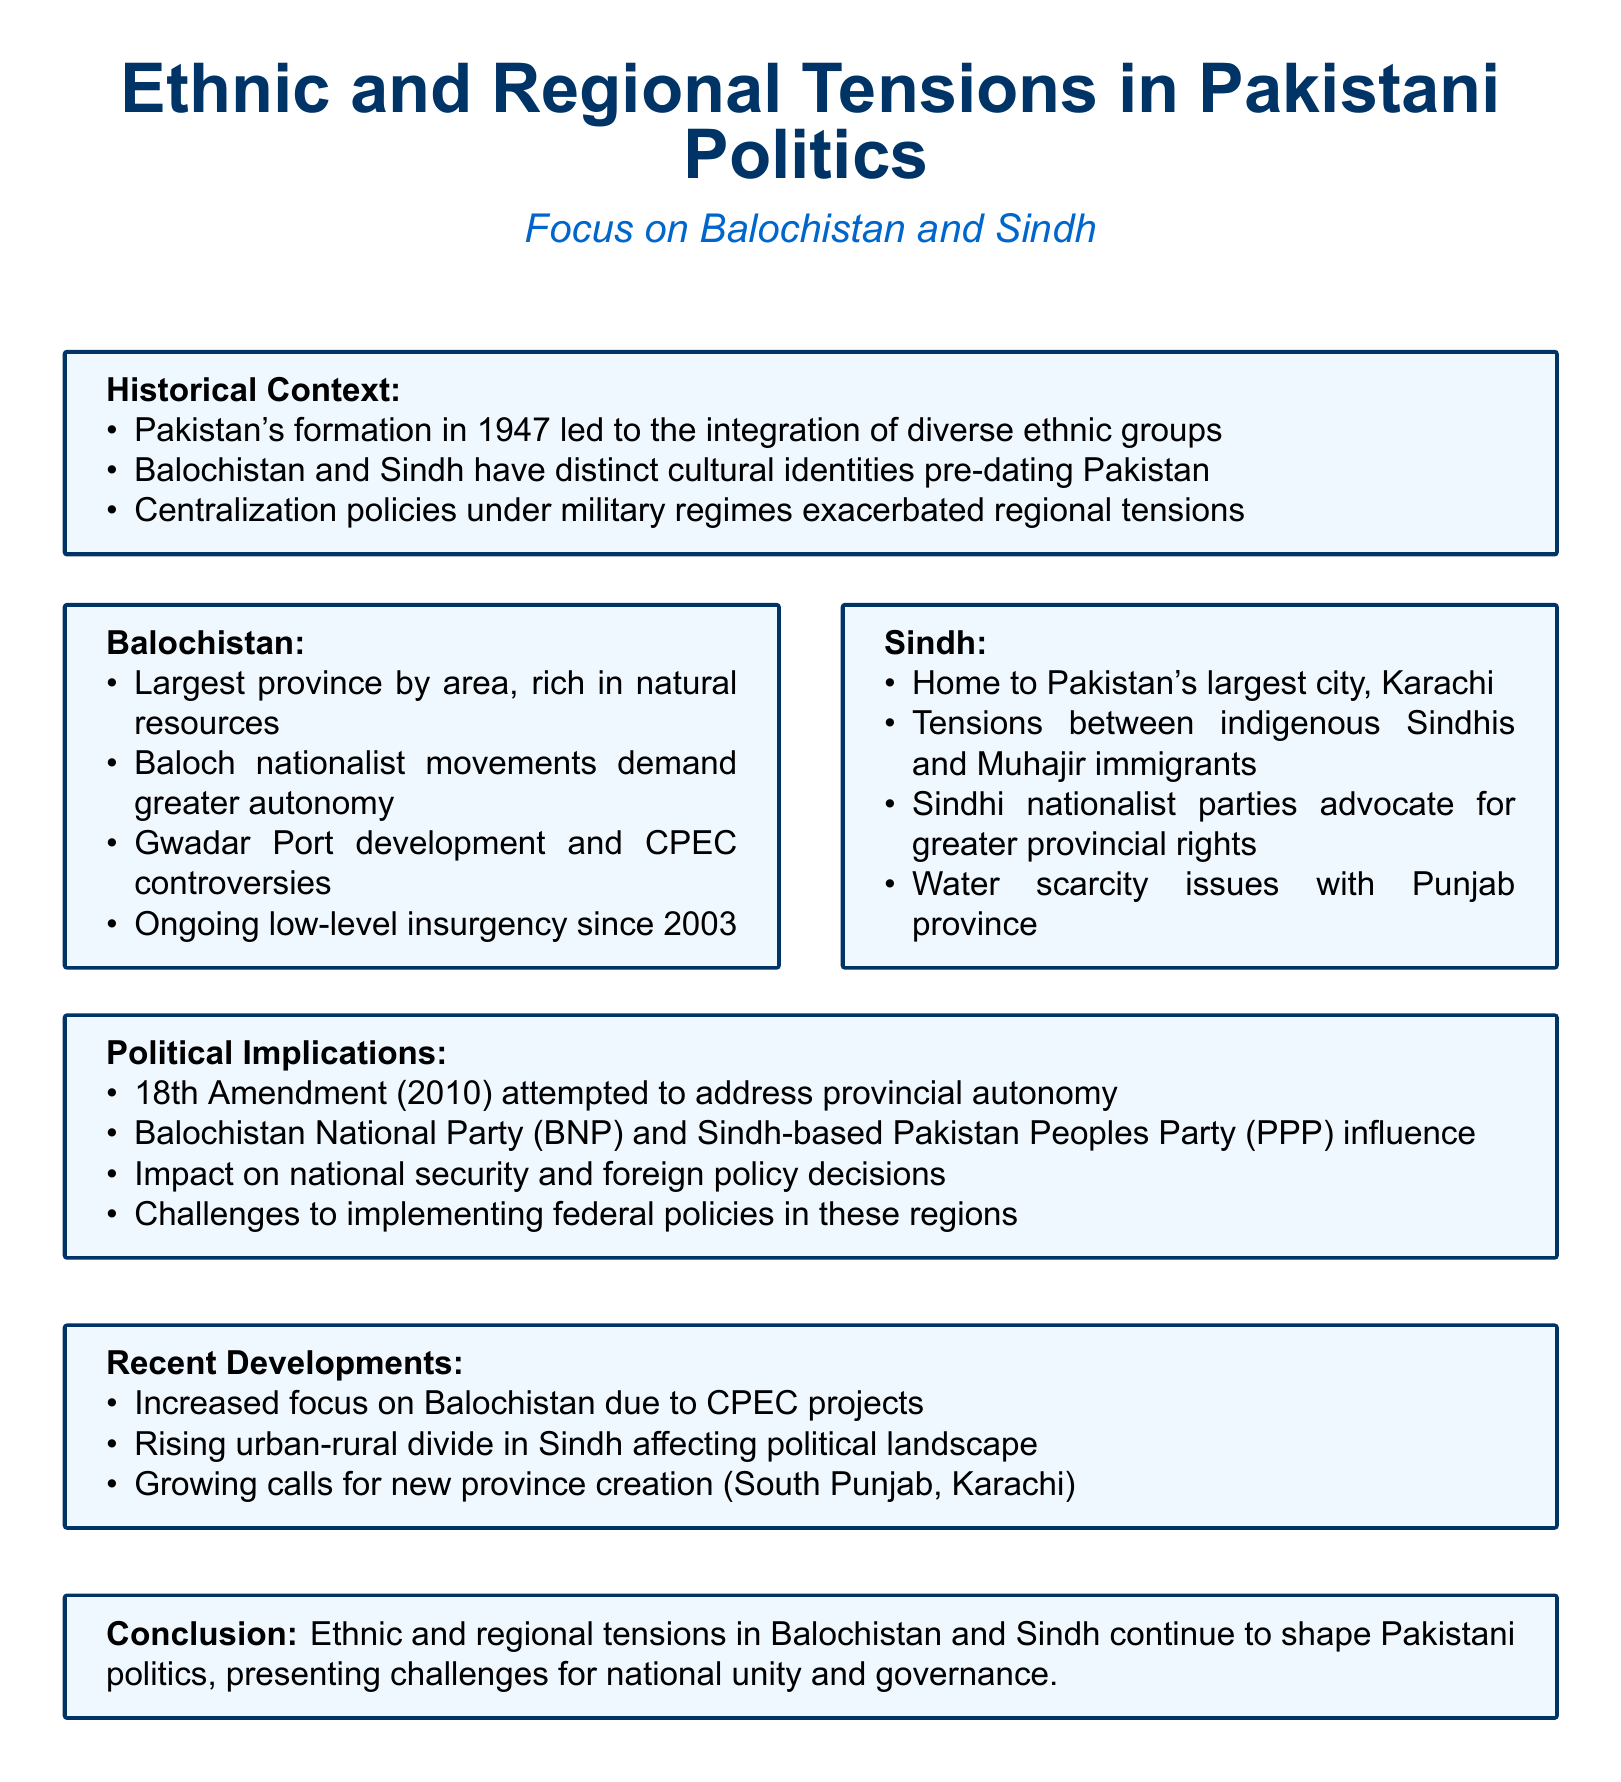What year did Pakistan form? The formation year of Pakistan is mentioned in the historical context section of the document.
Answer: 1947 What province is home to Karachi? The document notes that Karachi, the largest city, is located in Sindh province.
Answer: Sindh What is a major issue in Sindh relating to Punjab? The document addresses conflicts and resource allocation between provinces, specifically mentioning a scarcity issue.
Answer: Water scarcity Which amendment attempted to address provincial autonomy? The document refers to a significant constitutional amendment that aimed to improve provincial powers.
Answer: 18th Amendment What is a key focus of recent developments in Balochistan? The document highlights particular projects that have shifted attention toward the region recently.
Answer: CPEC projects What type of insurgency has been ongoing in Balochistan since 2003? The document classifies the armed conflict type occurring in Balochistan, which is characterized by low-level resistance.
Answer: Low-level insurgency What are Baloch nationalists demanding? The document specifies the aspirations of local movements in Balochistan regarding their governance.
Answer: Greater autonomy Which political party influences Sindh politics? The document cites a major political party that represents Sindhi interests in the province.
Answer: Pakistan Peoples Party (PPP) 